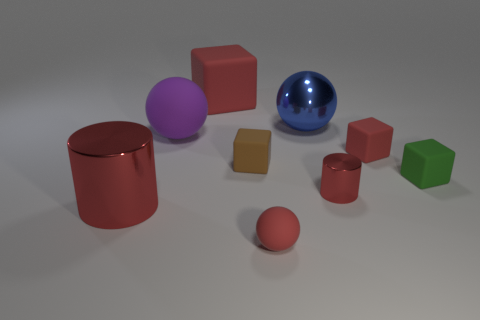Subtract 1 cubes. How many cubes are left? 3 Add 1 small red metallic cylinders. How many objects exist? 10 Subtract all balls. How many objects are left? 6 Subtract 0 blue blocks. How many objects are left? 9 Subtract all brown rubber cubes. Subtract all large red things. How many objects are left? 6 Add 2 red metallic cylinders. How many red metallic cylinders are left? 4 Add 8 big green shiny cylinders. How many big green shiny cylinders exist? 8 